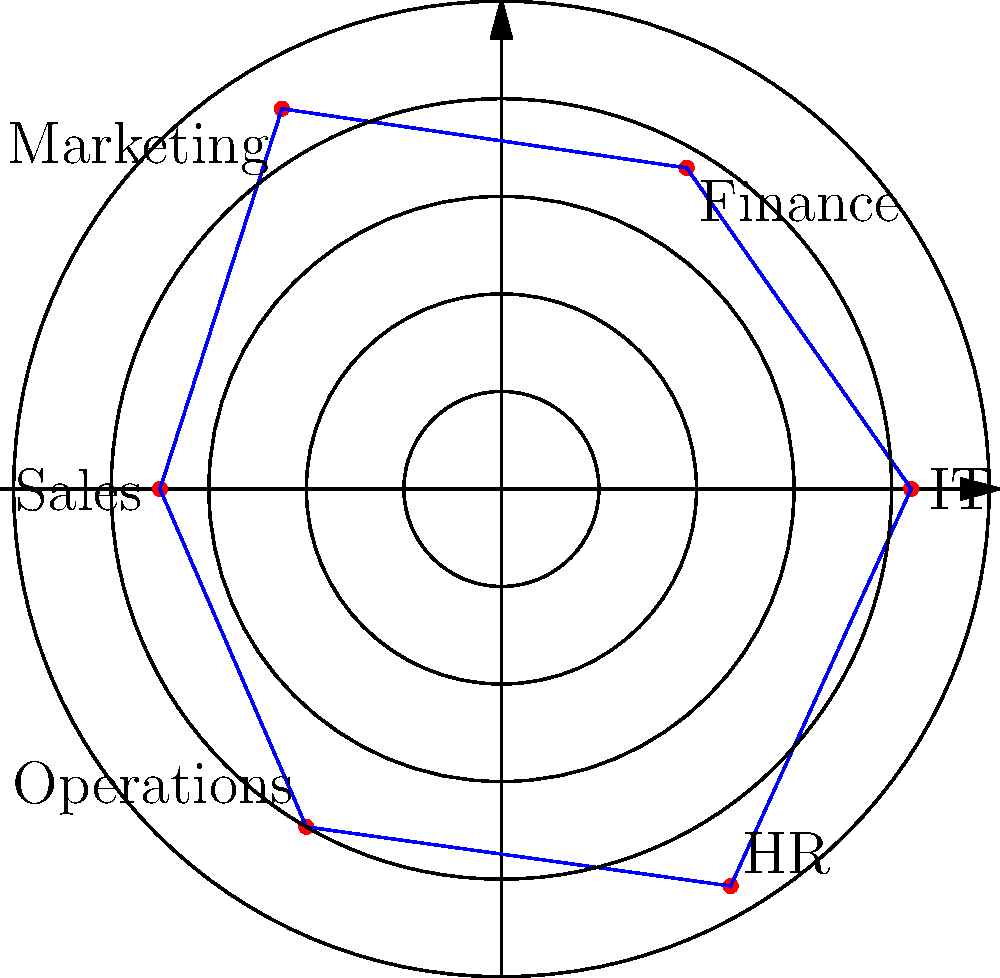In the polar coordinate visualization of employee satisfaction ratings across different departments, which department has the highest satisfaction rating, and what is its approximate value? To determine the department with the highest satisfaction rating, we need to analyze the polar coordinate graph:

1. Each department is represented by a point on the graph, with the angle indicating the department and the distance from the center representing the satisfaction rating.

2. The concentric circles represent satisfaction rating levels, with each circle increasing by 1 unit (1 to 5).

3. Examining each department's position:
   - HR: Furthest from the center, close to the 5th circle
   - IT: Between the 4th and 5th circles
   - Finance: Just below the 4th circle
   - Marketing: Slightly above the 4th circle
   - Sales: Between the 3rd and 4th circles
   - Operations: On the 4th circle

4. HR appears to have the highest rating, as its point is the furthest from the center.

5. The HR point is very close to, but slightly below, the 5th circle, indicating a rating of approximately 4.7.

Therefore, the HR department has the highest satisfaction rating of approximately 4.7.
Answer: HR department, 4.7 